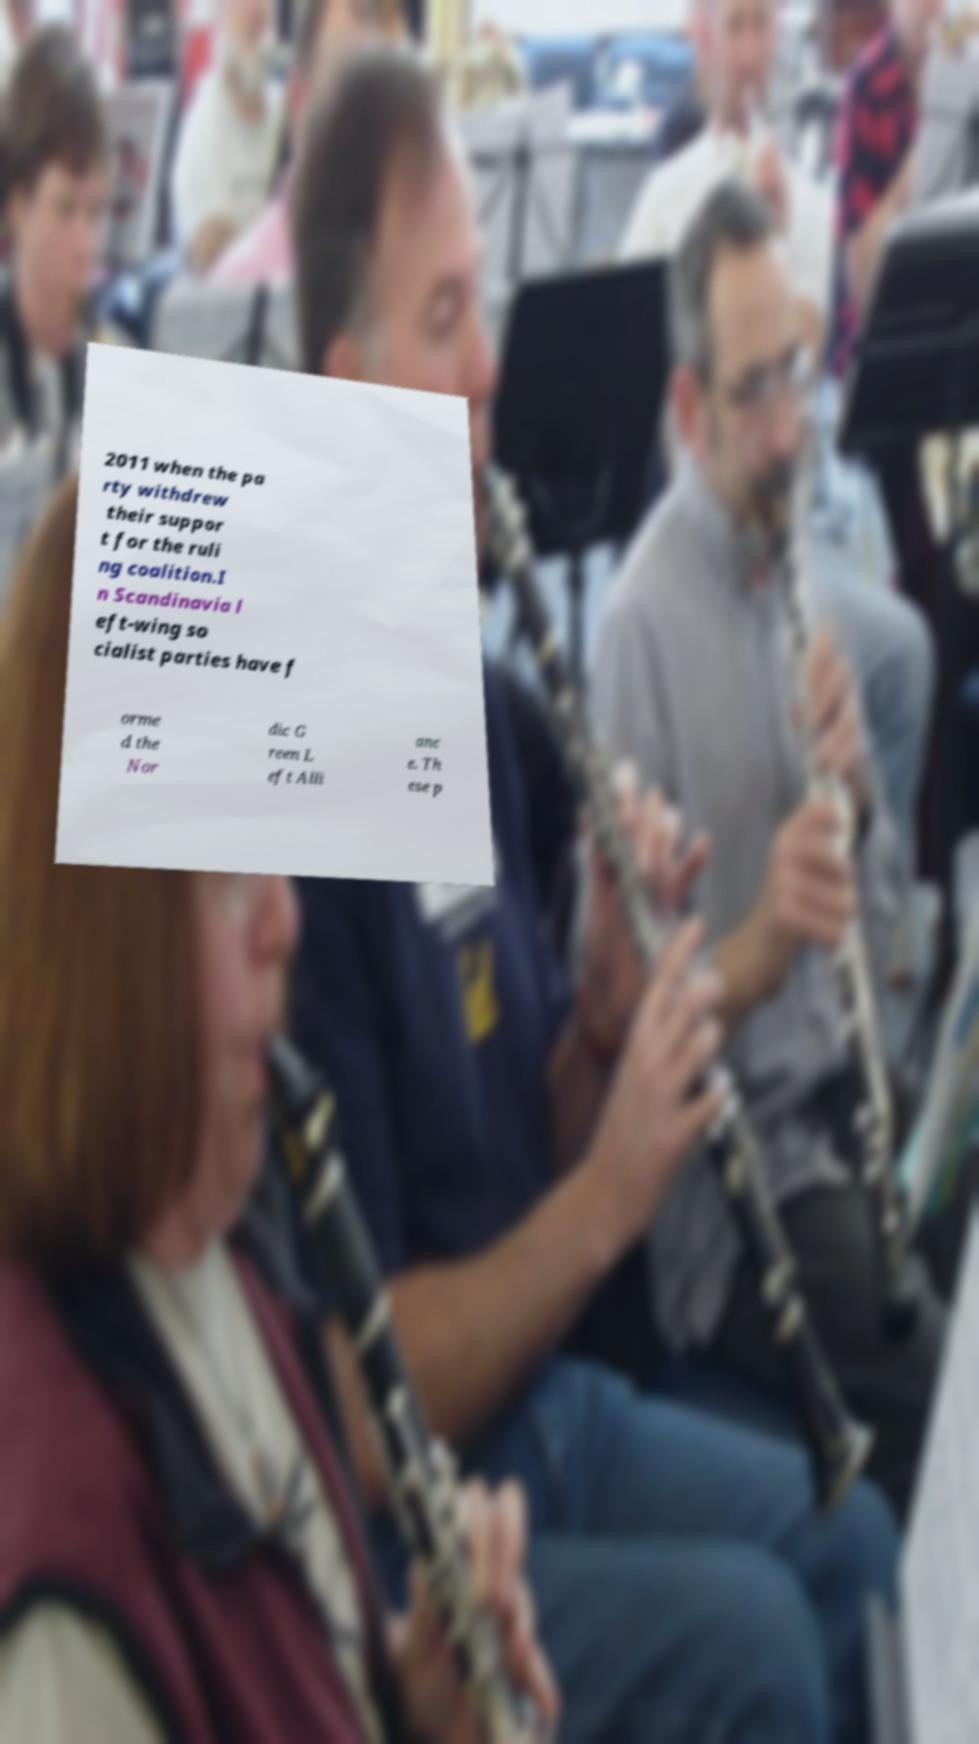What messages or text are displayed in this image? I need them in a readable, typed format. 2011 when the pa rty withdrew their suppor t for the ruli ng coalition.I n Scandinavia l eft-wing so cialist parties have f orme d the Nor dic G reen L eft Alli anc e. Th ese p 